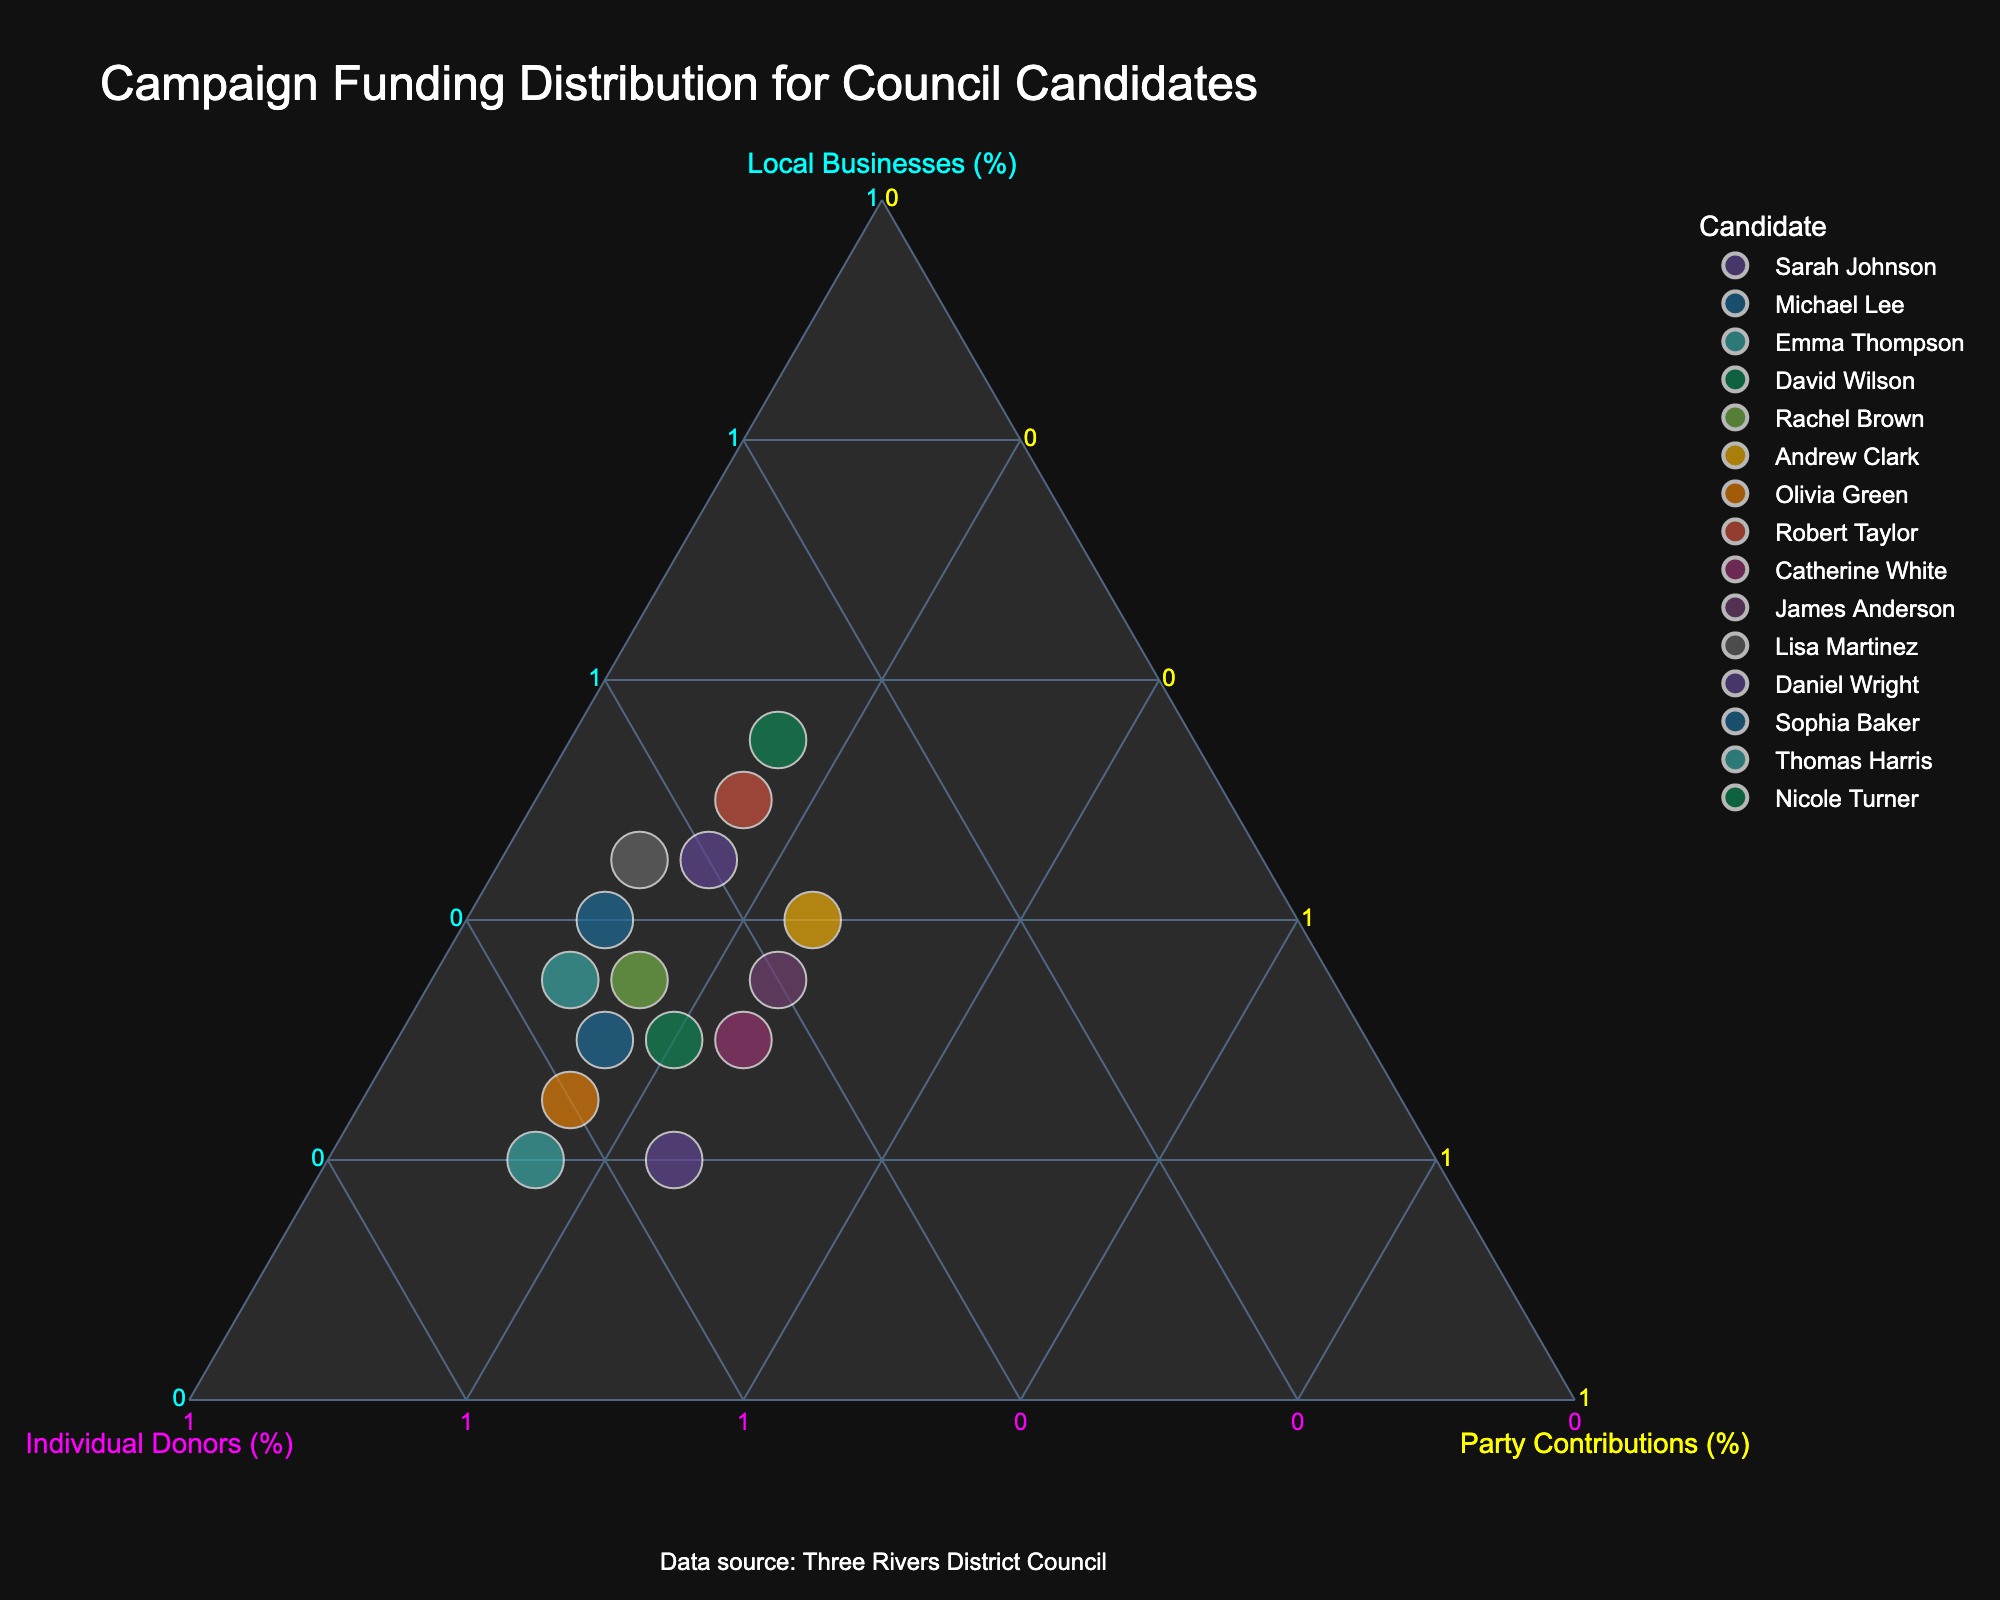What's the title of the chart? The title of the chart is mentioned at the top.
Answer: "Campaign Funding Distribution for Council Candidates" How many candidates' funding sources are displayed? This can be determined by counting the number of data points (marks) in the plot.
Answer: 15 What is the color used for the axis of 'Local Businesses (%)'? This can be determined by looking at the color of the label for the 'Local Businesses (%)' axis on the ternary plot.
Answer: Cyan Which candidate has the highest percentage from 'Individual Donors'? By hovering over each point or comparing positions, we can find the candidate with the highest position along the 'Individual Donors' axis.
Answer: Emma Thompson What are the three funding sources displayed on the plot? By observing the axis labels on the ternary plot, we can identify the three funding sources.
Answer: Local Businesses, Individual Donors, Party Contributions Who receives the least percentage from 'Party Contributions'? We need to find the candidate at the lowest point along the 'Party Contributions' axis.
Answer: Lisa Martinez and Sophia Baker Which candidate has an equal percentage from 'Local Businesses' and 'Individual Donors'? By looking for points where the distances to the 'Local Businesses (%)' and 'Individual Donors (%)' axes are equal.
Answer: Lisa Martinez What's the average percentage from 'Party Contributions' among all candidates? Sum all the percentages from 'Party Contributions' and divide by the number of candidates: (15*8 + 25*3 + 10*4)/15
Answer: 15 Does Sarah Johnson receive more funding from 'Local Businesses' or 'Individual Donors'? Comparing the corresponding values, Sarah Johnson receives 45% from 'Local Businesses' and 40% from 'Individual Donors'.
Answer: Local Businesses Which candidate has the most balanced distribution across all three funding sources? Find the data point closest to the center of the ternary plot, indicating even distribution among all funding sources.
Answer: Andrew Clark 